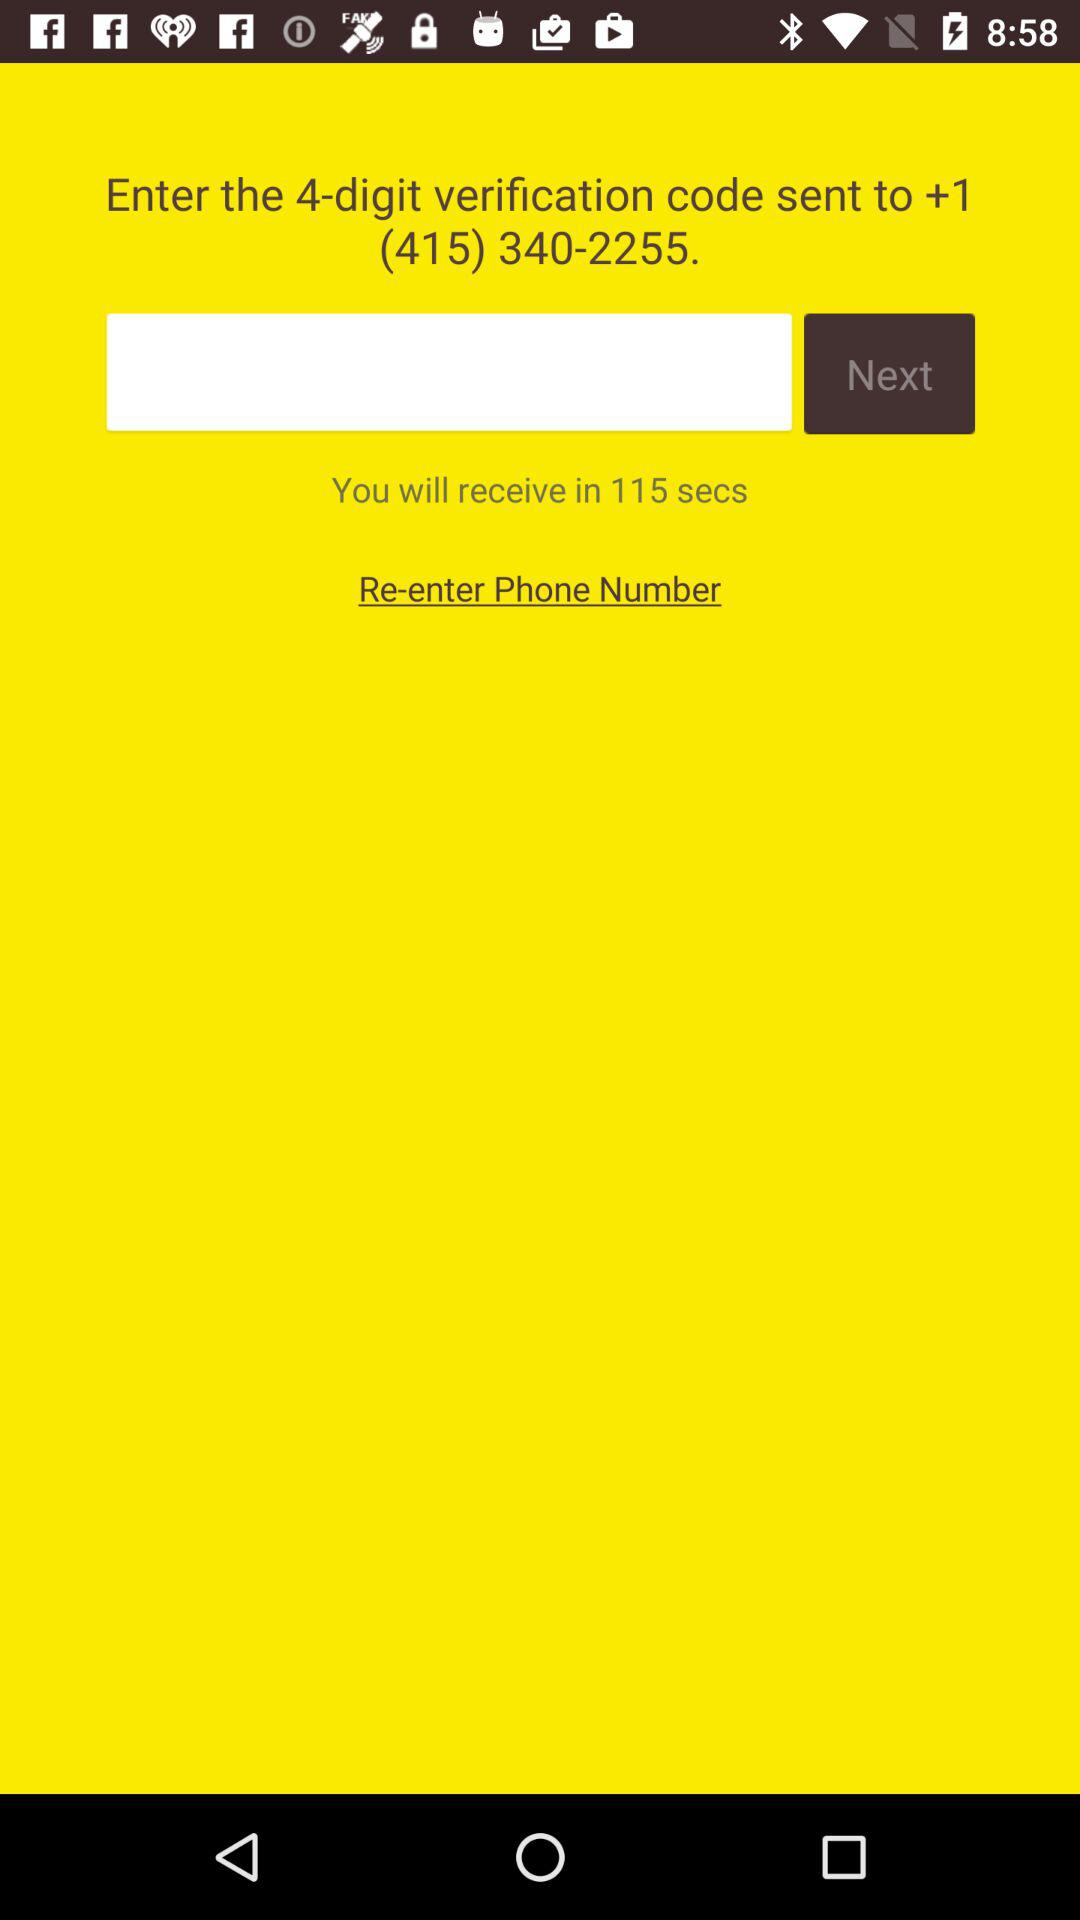When will we receive the code? You will receive the code in 115 seconds. 